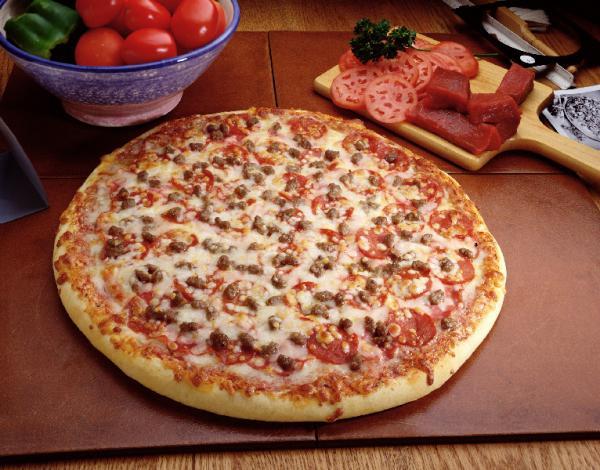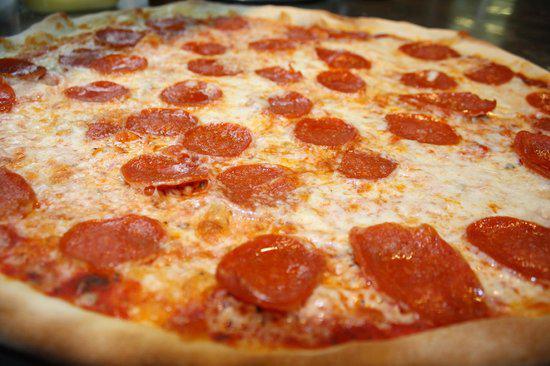The first image is the image on the left, the second image is the image on the right. Considering the images on both sides, is "The pizza in the image on the right is topped with round pepperoni slices." valid? Answer yes or no. Yes. The first image is the image on the left, the second image is the image on the right. Considering the images on both sides, is "One image shows a whole pizza, and the other image shows a pizza on a round gray tray, with multiple slices missing." valid? Answer yes or no. No. 